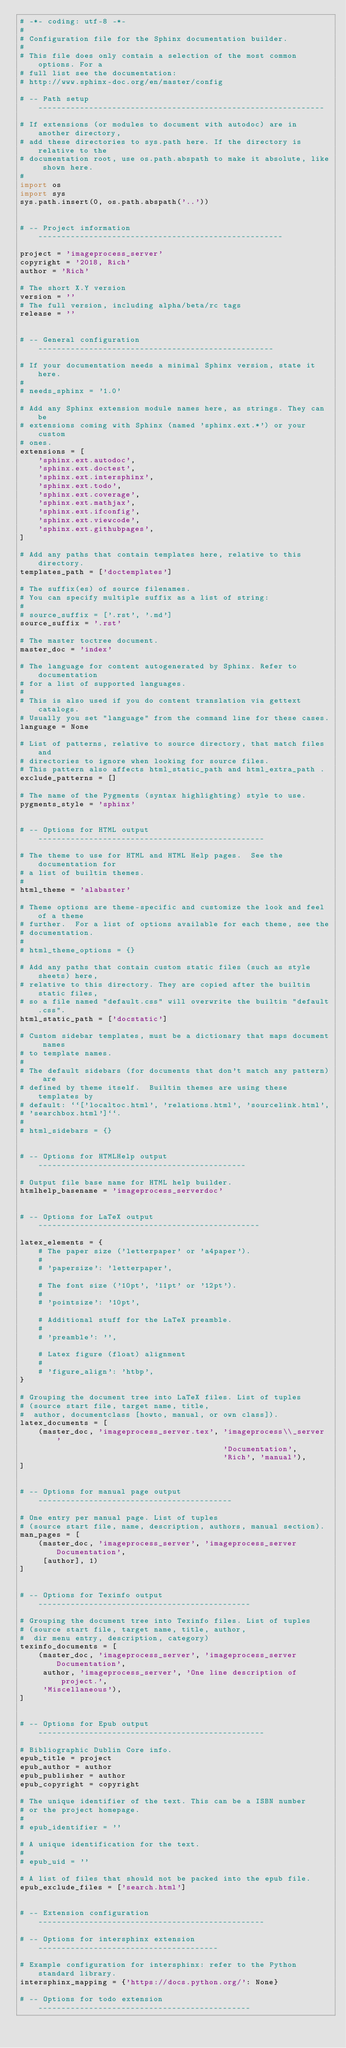Convert code to text. <code><loc_0><loc_0><loc_500><loc_500><_Python_># -*- coding: utf-8 -*-
#
# Configuration file for the Sphinx documentation builder.
#
# This file does only contain a selection of the most common options. For a
# full list see the documentation:
# http://www.sphinx-doc.org/en/master/config

# -- Path setup --------------------------------------------------------------

# If extensions (or modules to document with autodoc) are in another directory,
# add these directories to sys.path here. If the directory is relative to the
# documentation root, use os.path.abspath to make it absolute, like shown here.
#
import os
import sys
sys.path.insert(0, os.path.abspath('..'))


# -- Project information -----------------------------------------------------

project = 'imageprocess_server'
copyright = '2018, Rich'
author = 'Rich'

# The short X.Y version
version = ''
# The full version, including alpha/beta/rc tags
release = ''


# -- General configuration ---------------------------------------------------

# If your documentation needs a minimal Sphinx version, state it here.
#
# needs_sphinx = '1.0'

# Add any Sphinx extension module names here, as strings. They can be
# extensions coming with Sphinx (named 'sphinx.ext.*') or your custom
# ones.
extensions = [
    'sphinx.ext.autodoc',
    'sphinx.ext.doctest',
    'sphinx.ext.intersphinx',
    'sphinx.ext.todo',
    'sphinx.ext.coverage',
    'sphinx.ext.mathjax',
    'sphinx.ext.ifconfig',
    'sphinx.ext.viewcode',
    'sphinx.ext.githubpages',
]

# Add any paths that contain templates here, relative to this directory.
templates_path = ['doctemplates']

# The suffix(es) of source filenames.
# You can specify multiple suffix as a list of string:
#
# source_suffix = ['.rst', '.md']
source_suffix = '.rst'

# The master toctree document.
master_doc = 'index'

# The language for content autogenerated by Sphinx. Refer to documentation
# for a list of supported languages.
#
# This is also used if you do content translation via gettext catalogs.
# Usually you set "language" from the command line for these cases.
language = None

# List of patterns, relative to source directory, that match files and
# directories to ignore when looking for source files.
# This pattern also affects html_static_path and html_extra_path .
exclude_patterns = []

# The name of the Pygments (syntax highlighting) style to use.
pygments_style = 'sphinx'


# -- Options for HTML output -------------------------------------------------

# The theme to use for HTML and HTML Help pages.  See the documentation for
# a list of builtin themes.
#
html_theme = 'alabaster'

# Theme options are theme-specific and customize the look and feel of a theme
# further.  For a list of options available for each theme, see the
# documentation.
#
# html_theme_options = {}

# Add any paths that contain custom static files (such as style sheets) here,
# relative to this directory. They are copied after the builtin static files,
# so a file named "default.css" will overwrite the builtin "default.css".
html_static_path = ['docstatic']

# Custom sidebar templates, must be a dictionary that maps document names
# to template names.
#
# The default sidebars (for documents that don't match any pattern) are
# defined by theme itself.  Builtin themes are using these templates by
# default: ``['localtoc.html', 'relations.html', 'sourcelink.html',
# 'searchbox.html']``.
#
# html_sidebars = {}


# -- Options for HTMLHelp output ---------------------------------------------

# Output file base name for HTML help builder.
htmlhelp_basename = 'imageprocess_serverdoc'


# -- Options for LaTeX output ------------------------------------------------

latex_elements = {
    # The paper size ('letterpaper' or 'a4paper').
    #
    # 'papersize': 'letterpaper',

    # The font size ('10pt', '11pt' or '12pt').
    #
    # 'pointsize': '10pt',

    # Additional stuff for the LaTeX preamble.
    #
    # 'preamble': '',

    # Latex figure (float) alignment
    #
    # 'figure_align': 'htbp',
}

# Grouping the document tree into LaTeX files. List of tuples
# (source start file, target name, title,
#  author, documentclass [howto, manual, or own class]).
latex_documents = [
    (master_doc, 'imageprocess_server.tex', 'imageprocess\\_server '
                                            'Documentation',
                                            'Rich', 'manual'),
]


# -- Options for manual page output ------------------------------------------

# One entry per manual page. List of tuples
# (source start file, name, description, authors, manual section).
man_pages = [
    (master_doc, 'imageprocess_server', 'imageprocess_server Documentation',
     [author], 1)
]


# -- Options for Texinfo output ----------------------------------------------

# Grouping the document tree into Texinfo files. List of tuples
# (source start file, target name, title, author,
#  dir menu entry, description, category)
texinfo_documents = [
    (master_doc, 'imageprocess_server', 'imageprocess_server Documentation',
     author, 'imageprocess_server', 'One line description of project.',
     'Miscellaneous'),
]


# -- Options for Epub output -------------------------------------------------

# Bibliographic Dublin Core info.
epub_title = project
epub_author = author
epub_publisher = author
epub_copyright = copyright

# The unique identifier of the text. This can be a ISBN number
# or the project homepage.
#
# epub_identifier = ''

# A unique identification for the text.
#
# epub_uid = ''

# A list of files that should not be packed into the epub file.
epub_exclude_files = ['search.html']


# -- Extension configuration -------------------------------------------------

# -- Options for intersphinx extension ---------------------------------------

# Example configuration for intersphinx: refer to the Python standard library.
intersphinx_mapping = {'https://docs.python.org/': None}

# -- Options for todo extension ----------------------------------------------
</code> 